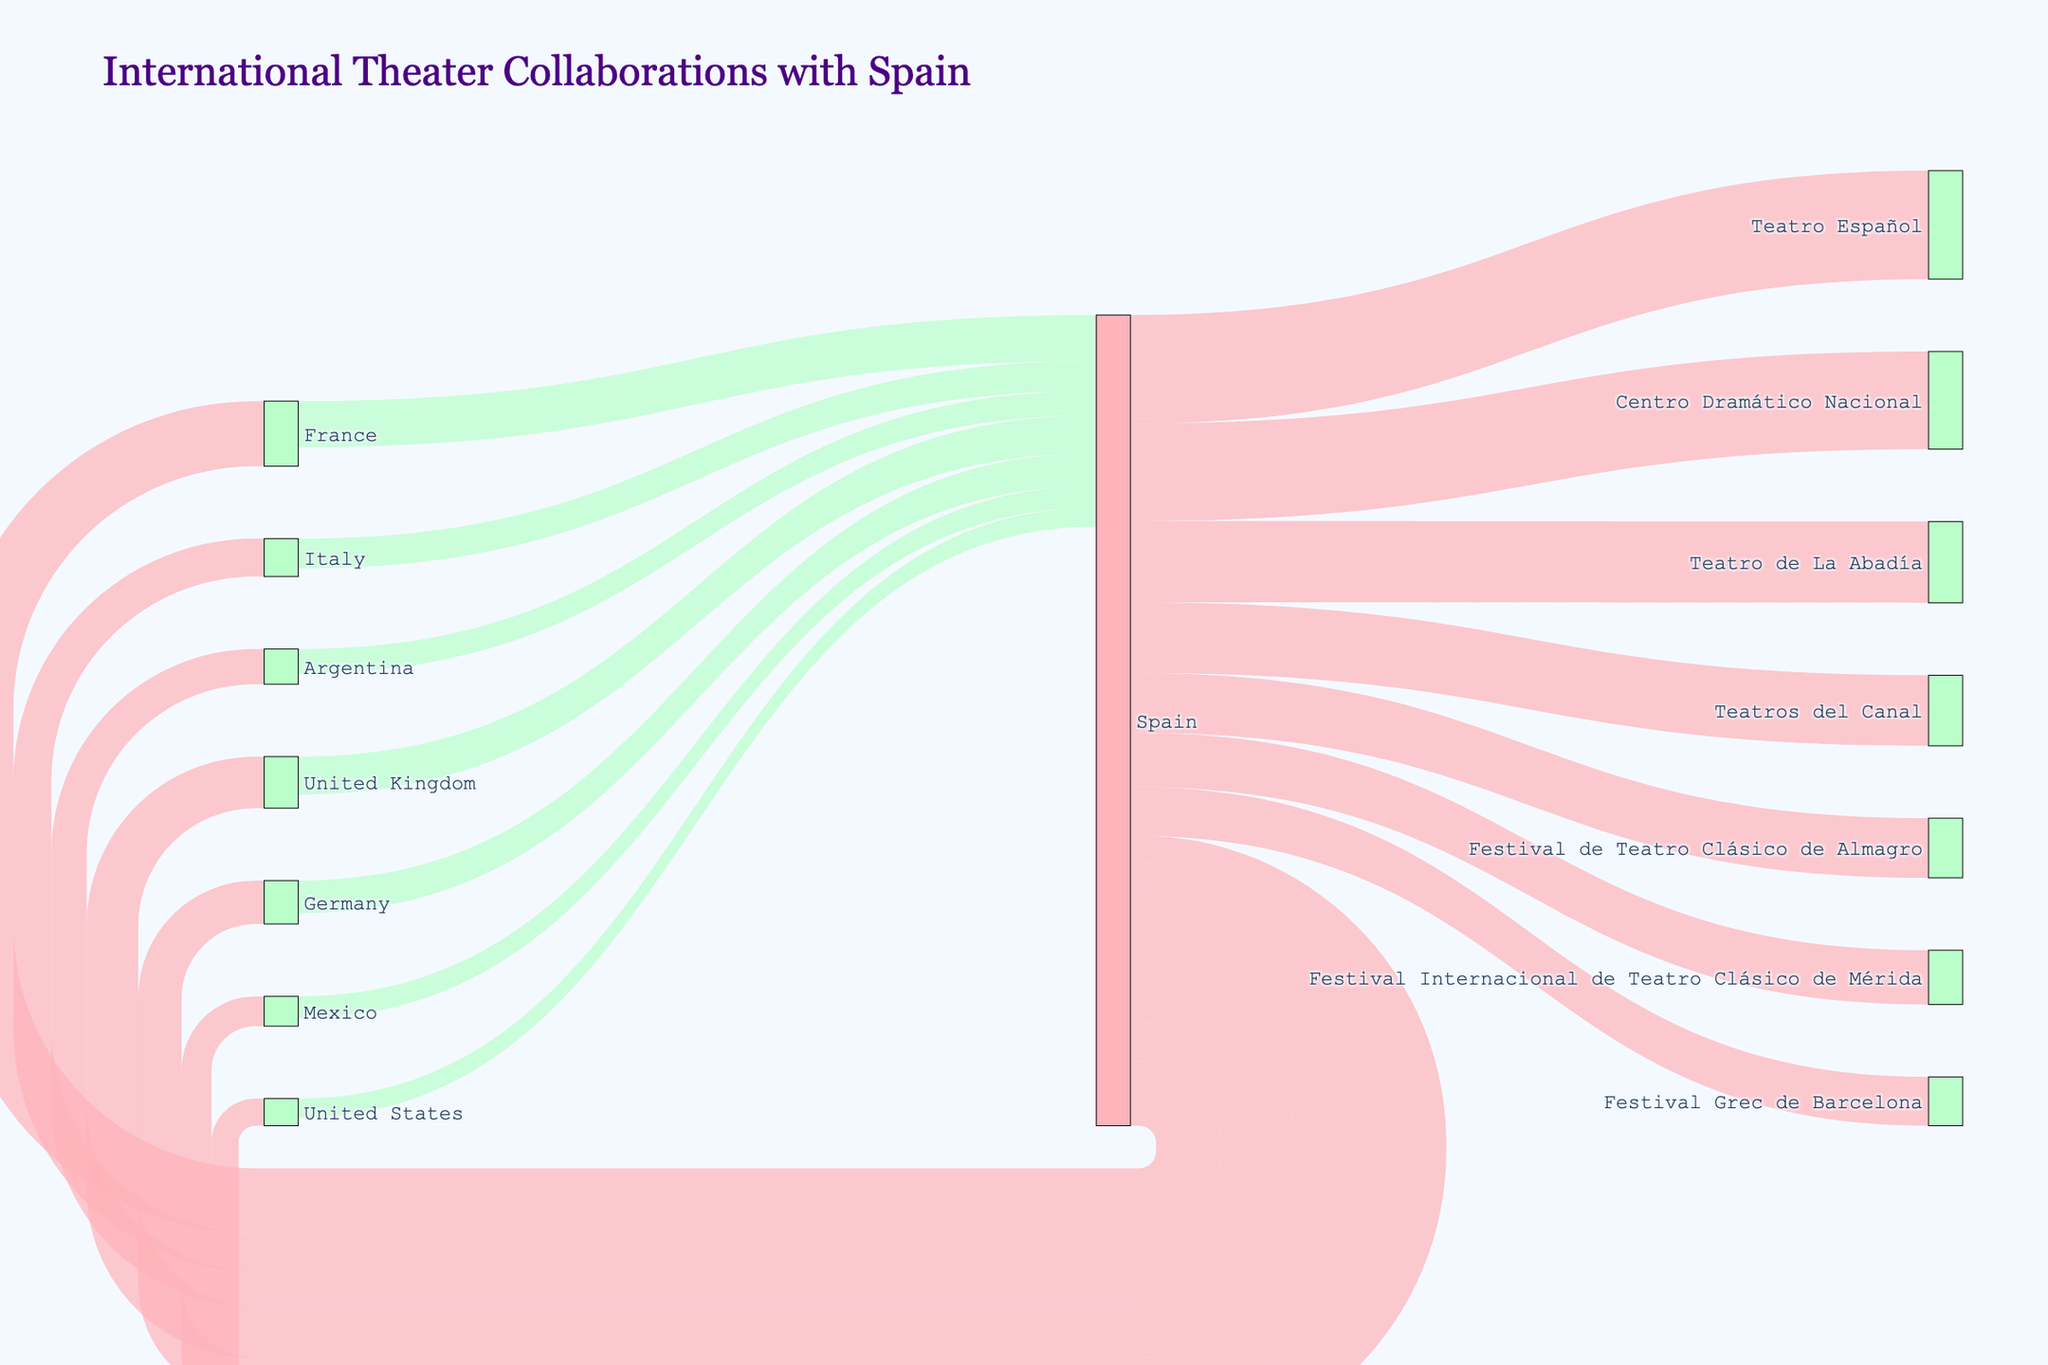How many international collaborations does Spain have with France? The figure shows the flow values between different countries. To find the collaborations between Spain and France, look at the link connecting them.
Answer: 120 What is the total number of collaborations between Spain and all other countries combined? Add up all the values flowing from Spain to other countries: 120 (France) + 95 (United Kingdom) + 80 (Germany) + 70 (Italy) + 65 (Argentina) + 55 (Mexico) + 50 (United States) = 535
Answer: 535 Which country has the lowest number of theater collaborations with Spain? Look at the flow values connected to Spain and identify the smallest one.
Answer: United States How many collaborations does the Centro Dramático Nacional receive from Spain? Find the flow value connecting Spain to Centro Dramático Nacional.
Answer: 180 What is the sum of collaborations between Spain and Italy, and Italy to Spain? Add the values of both flows: 70 (Spain to Italy) + 55 (Italy to Spain) = 125
Answer: 125 Which Spanish theatre has the highest number of collaborations from Spain? Find the theatre with the largest value flowing from Spain.
Answer: Teatro Español How does the number of collaborations with Germany compare between collaborations to and from Spain? Compare the values: 80 (Spain to Germany) vs 60 (Germany to Spain). Spain to Germany has more collaborations.
Answer: Spain to Germany What is the average number of collaborations from Spain to the listed Spanish theaters? Sum the values and divide by the total number of theatres: (200 + 180 + 150 + 130 + 110 + 100 + 90) / 7 = 137.14
Answer: 137.14 (rounded to two decimal places) How does the collaboration flow between Spain and the United Kingdom compare to that between Spain and Argentina? Compare the flows: 95 (Spain to United Kingdom) vs 65 (Spain to Argentina). Spain collaborates more with the United Kingdom.
Answer: United Kingdom How many countries have fewer than 60 collaborations with Spain? Identify the countries with values less than 60: United States, Mexico, Argentina, and Italy. Count them.
Answer: 4 